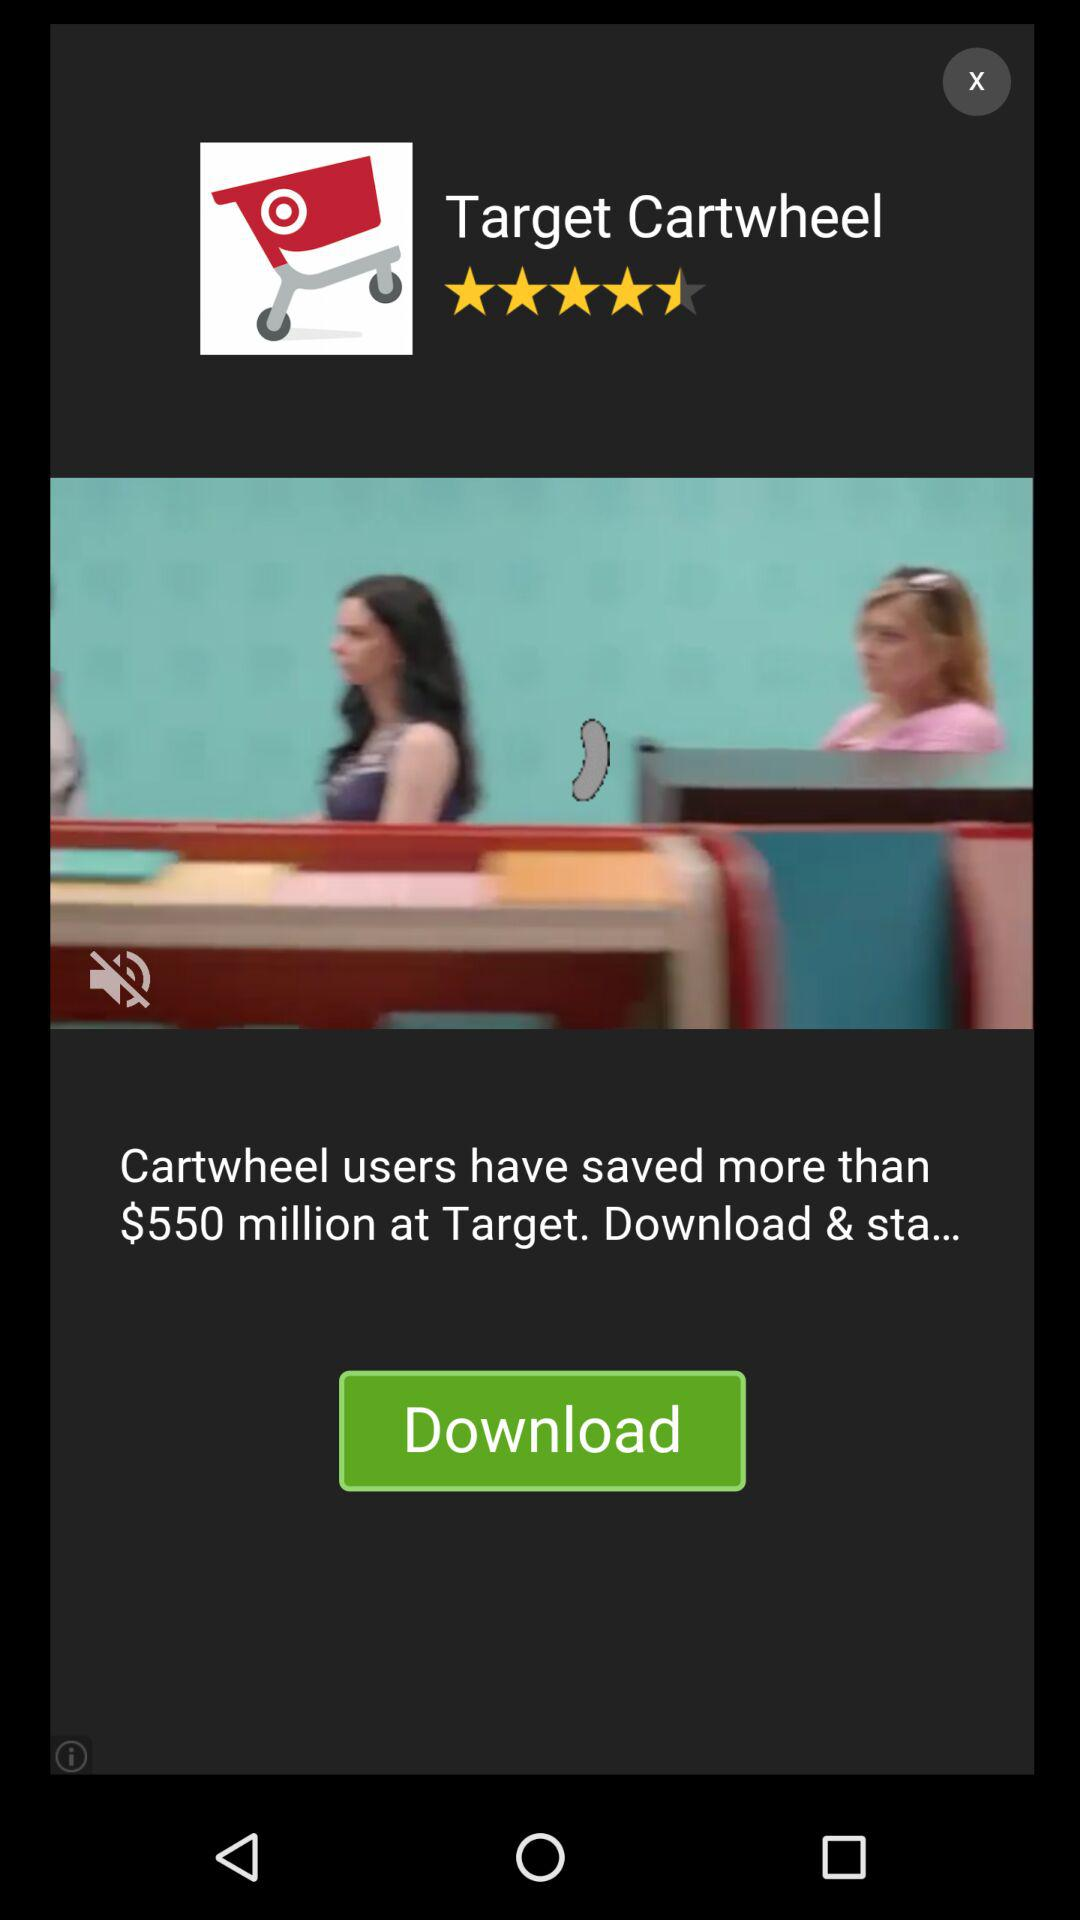How much have "Target Cartwheel" users saved? "Target Cartwheel" users have saved more than $550 million. 